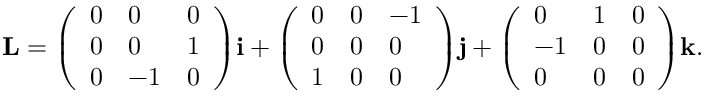Convert formula to latex. <formula><loc_0><loc_0><loc_500><loc_500>L = { \left ( \begin{array} { l l l } { 0 } & { 0 } & { 0 } \\ { 0 } & { 0 } & { 1 } \\ { 0 } & { - 1 } & { 0 } \end{array} \right ) } i + { \left ( \begin{array} { l l l } { 0 } & { 0 } & { - 1 } \\ { 0 } & { 0 } & { 0 } \\ { 1 } & { 0 } & { 0 } \end{array} \right ) } j + { \left ( \begin{array} { l l l } { 0 } & { 1 } & { 0 } \\ { - 1 } & { 0 } & { 0 } \\ { 0 } & { 0 } & { 0 } \end{array} \right ) } k .</formula> 